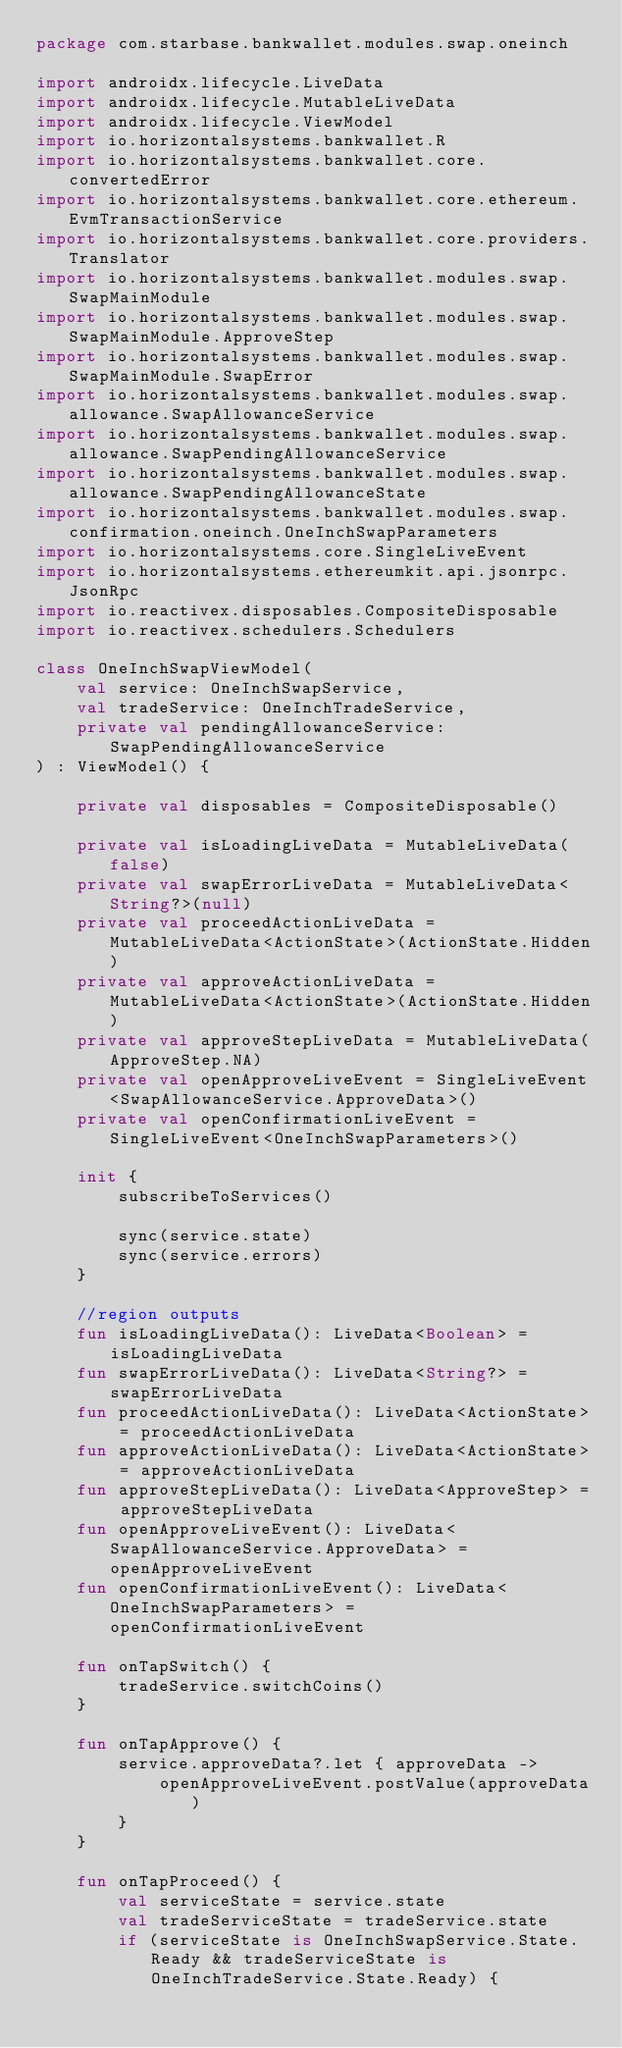<code> <loc_0><loc_0><loc_500><loc_500><_Kotlin_>package com.starbase.bankwallet.modules.swap.oneinch

import androidx.lifecycle.LiveData
import androidx.lifecycle.MutableLiveData
import androidx.lifecycle.ViewModel
import io.horizontalsystems.bankwallet.R
import io.horizontalsystems.bankwallet.core.convertedError
import io.horizontalsystems.bankwallet.core.ethereum.EvmTransactionService
import io.horizontalsystems.bankwallet.core.providers.Translator
import io.horizontalsystems.bankwallet.modules.swap.SwapMainModule
import io.horizontalsystems.bankwallet.modules.swap.SwapMainModule.ApproveStep
import io.horizontalsystems.bankwallet.modules.swap.SwapMainModule.SwapError
import io.horizontalsystems.bankwallet.modules.swap.allowance.SwapAllowanceService
import io.horizontalsystems.bankwallet.modules.swap.allowance.SwapPendingAllowanceService
import io.horizontalsystems.bankwallet.modules.swap.allowance.SwapPendingAllowanceState
import io.horizontalsystems.bankwallet.modules.swap.confirmation.oneinch.OneInchSwapParameters
import io.horizontalsystems.core.SingleLiveEvent
import io.horizontalsystems.ethereumkit.api.jsonrpc.JsonRpc
import io.reactivex.disposables.CompositeDisposable
import io.reactivex.schedulers.Schedulers

class OneInchSwapViewModel(
    val service: OneInchSwapService,
    val tradeService: OneInchTradeService,
    private val pendingAllowanceService: SwapPendingAllowanceService
) : ViewModel() {

    private val disposables = CompositeDisposable()

    private val isLoadingLiveData = MutableLiveData(false)
    private val swapErrorLiveData = MutableLiveData<String?>(null)
    private val proceedActionLiveData = MutableLiveData<ActionState>(ActionState.Hidden)
    private val approveActionLiveData = MutableLiveData<ActionState>(ActionState.Hidden)
    private val approveStepLiveData = MutableLiveData(ApproveStep.NA)
    private val openApproveLiveEvent = SingleLiveEvent<SwapAllowanceService.ApproveData>()
    private val openConfirmationLiveEvent = SingleLiveEvent<OneInchSwapParameters>()

    init {
        subscribeToServices()

        sync(service.state)
        sync(service.errors)
    }

    //region outputs
    fun isLoadingLiveData(): LiveData<Boolean> = isLoadingLiveData
    fun swapErrorLiveData(): LiveData<String?> = swapErrorLiveData
    fun proceedActionLiveData(): LiveData<ActionState> = proceedActionLiveData
    fun approveActionLiveData(): LiveData<ActionState> = approveActionLiveData
    fun approveStepLiveData(): LiveData<ApproveStep> = approveStepLiveData
    fun openApproveLiveEvent(): LiveData<SwapAllowanceService.ApproveData> = openApproveLiveEvent
    fun openConfirmationLiveEvent(): LiveData<OneInchSwapParameters> = openConfirmationLiveEvent

    fun onTapSwitch() {
        tradeService.switchCoins()
    }

    fun onTapApprove() {
        service.approveData?.let { approveData ->
            openApproveLiveEvent.postValue(approveData)
        }
    }

    fun onTapProceed() {
        val serviceState = service.state
        val tradeServiceState = tradeService.state
        if (serviceState is OneInchSwapService.State.Ready && tradeServiceState is OneInchTradeService.State.Ready) {</code> 